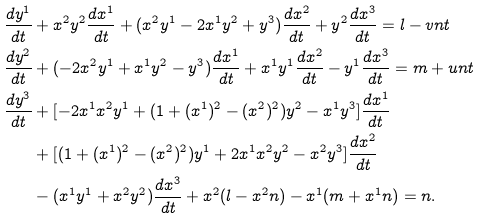Convert formula to latex. <formula><loc_0><loc_0><loc_500><loc_500>\frac { d y ^ { 1 } } { d t } & + x ^ { 2 } y ^ { 2 } \frac { d x ^ { 1 } } { d t } + ( x ^ { 2 } y ^ { 1 } - 2 x ^ { 1 } y ^ { 2 } + y ^ { 3 } ) \frac { d x ^ { 2 } } { d t } + y ^ { 2 } \frac { d x ^ { 3 } } { d t } = l - v n t \\ \frac { d y ^ { 2 } } { d t } & + ( - 2 x ^ { 2 } y ^ { 1 } + x ^ { 1 } y ^ { 2 } - y ^ { 3 } ) \frac { d x ^ { 1 } } { d t } + x ^ { 1 } y ^ { 1 } \frac { d x ^ { 2 } } { d t } - y ^ { 1 } \frac { d x ^ { 3 } } { d t } = m + u n t \\ \frac { d y ^ { 3 } } { d t } & + [ - 2 x ^ { 1 } x ^ { 2 } y ^ { 1 } + ( 1 + ( x ^ { 1 } ) ^ { 2 } - ( x ^ { 2 } ) ^ { 2 } ) y ^ { 2 } - x ^ { 1 } y ^ { 3 } ] \frac { d x ^ { 1 } } { d t } \\ & + [ ( 1 + ( x ^ { 1 } ) ^ { 2 } - ( x ^ { 2 } ) ^ { 2 } ) y ^ { 1 } + 2 x ^ { 1 } x ^ { 2 } y ^ { 2 } - x ^ { 2 } y ^ { 3 } ] \frac { d x ^ { 2 } } { d t } \\ & - ( x ^ { 1 } y ^ { 1 } + x ^ { 2 } y ^ { 2 } ) \frac { d x ^ { 3 } } { d t } + x ^ { 2 } ( l - x ^ { 2 } n ) - x ^ { 1 } ( m + x ^ { 1 } n ) = n .</formula> 